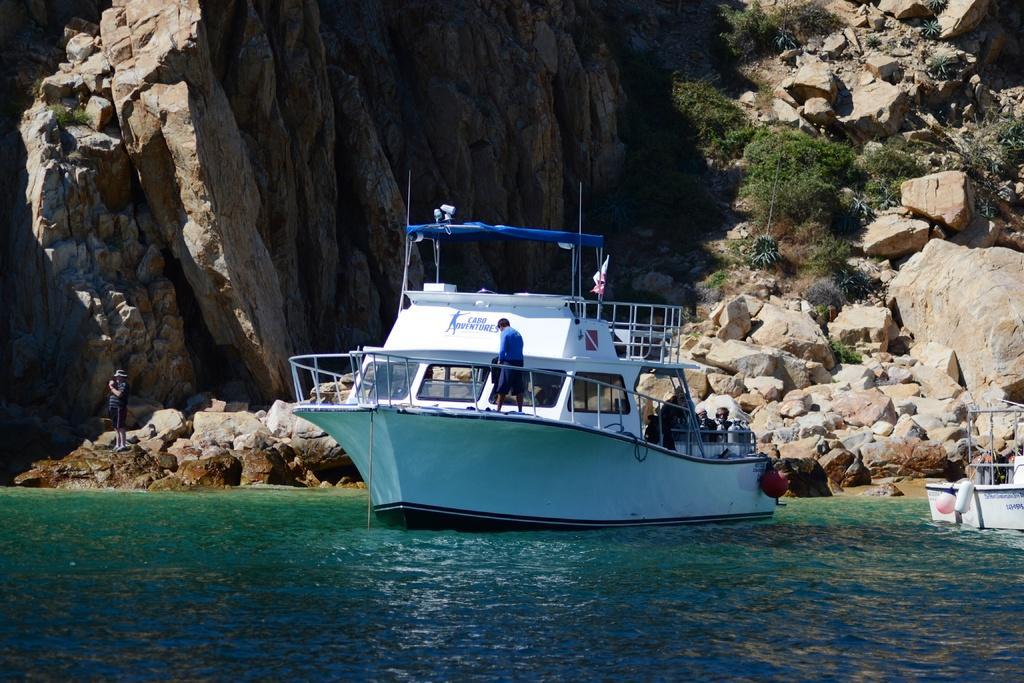Can you describe this image briefly? In this image, I can see two boats on the water. I can see the rocks and bushes. On the left side of the image, I can see a person standing. I think this is a hill. I can see another person standing on a boat. 